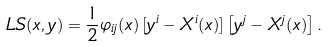<formula> <loc_0><loc_0><loc_500><loc_500>L S ( x , y ) = \frac { 1 } { 2 } \varphi _ { i j } ( x ) \left [ y ^ { i } - X ^ { i } ( x ) \right ] \left [ y ^ { j } - X ^ { j } ( x ) \right ] .</formula> 